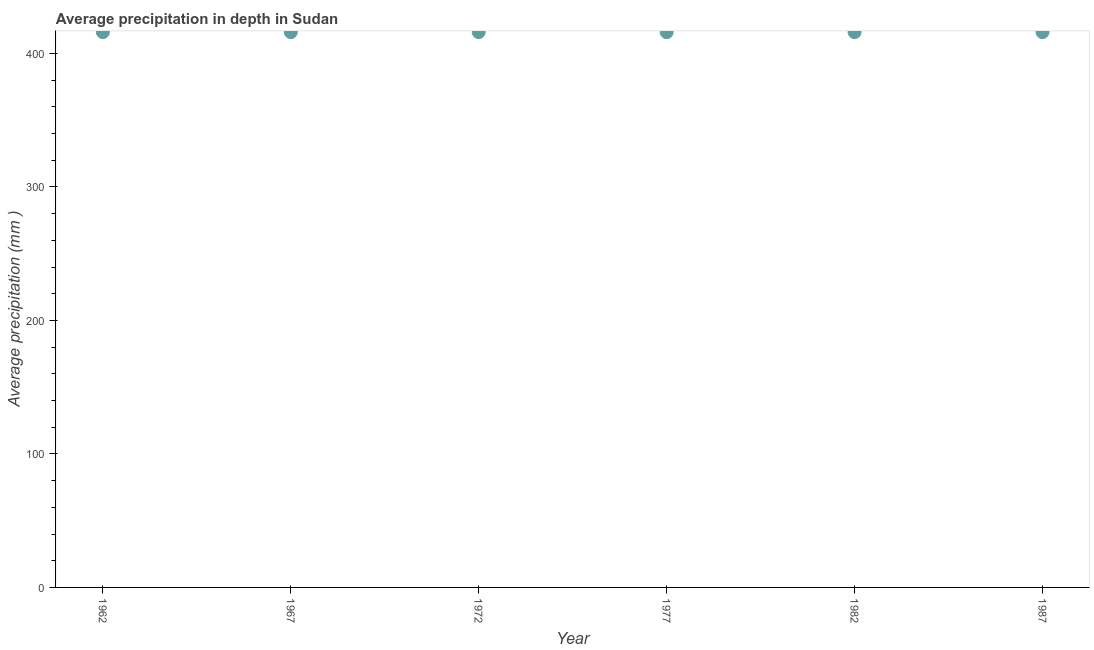What is the average precipitation in depth in 1967?
Give a very brief answer. 416. Across all years, what is the maximum average precipitation in depth?
Your answer should be compact. 416. Across all years, what is the minimum average precipitation in depth?
Make the answer very short. 416. In which year was the average precipitation in depth minimum?
Keep it short and to the point. 1962. What is the sum of the average precipitation in depth?
Ensure brevity in your answer.  2496. What is the difference between the average precipitation in depth in 1967 and 1987?
Give a very brief answer. 0. What is the average average precipitation in depth per year?
Provide a succinct answer. 416. What is the median average precipitation in depth?
Your answer should be very brief. 416. In how many years, is the average precipitation in depth greater than 280 mm?
Offer a terse response. 6. Do a majority of the years between 1962 and 1982 (inclusive) have average precipitation in depth greater than 40 mm?
Give a very brief answer. Yes. What is the ratio of the average precipitation in depth in 1967 to that in 1977?
Make the answer very short. 1. Is the difference between the average precipitation in depth in 1967 and 1987 greater than the difference between any two years?
Offer a very short reply. Yes. What is the difference between the highest and the second highest average precipitation in depth?
Your response must be concise. 0. What is the title of the graph?
Make the answer very short. Average precipitation in depth in Sudan. What is the label or title of the X-axis?
Make the answer very short. Year. What is the label or title of the Y-axis?
Your answer should be compact. Average precipitation (mm ). What is the Average precipitation (mm ) in 1962?
Offer a terse response. 416. What is the Average precipitation (mm ) in 1967?
Offer a terse response. 416. What is the Average precipitation (mm ) in 1972?
Offer a very short reply. 416. What is the Average precipitation (mm ) in 1977?
Keep it short and to the point. 416. What is the Average precipitation (mm ) in 1982?
Make the answer very short. 416. What is the Average precipitation (mm ) in 1987?
Your answer should be very brief. 416. What is the difference between the Average precipitation (mm ) in 1962 and 1982?
Your answer should be very brief. 0. What is the difference between the Average precipitation (mm ) in 1962 and 1987?
Keep it short and to the point. 0. What is the difference between the Average precipitation (mm ) in 1967 and 1982?
Give a very brief answer. 0. What is the difference between the Average precipitation (mm ) in 1972 and 1977?
Provide a succinct answer. 0. What is the difference between the Average precipitation (mm ) in 1977 and 1982?
Provide a short and direct response. 0. What is the difference between the Average precipitation (mm ) in 1977 and 1987?
Ensure brevity in your answer.  0. What is the difference between the Average precipitation (mm ) in 1982 and 1987?
Give a very brief answer. 0. What is the ratio of the Average precipitation (mm ) in 1962 to that in 1982?
Provide a succinct answer. 1. What is the ratio of the Average precipitation (mm ) in 1967 to that in 1987?
Your answer should be very brief. 1. What is the ratio of the Average precipitation (mm ) in 1972 to that in 1977?
Your answer should be compact. 1. What is the ratio of the Average precipitation (mm ) in 1972 to that in 1982?
Provide a succinct answer. 1. 